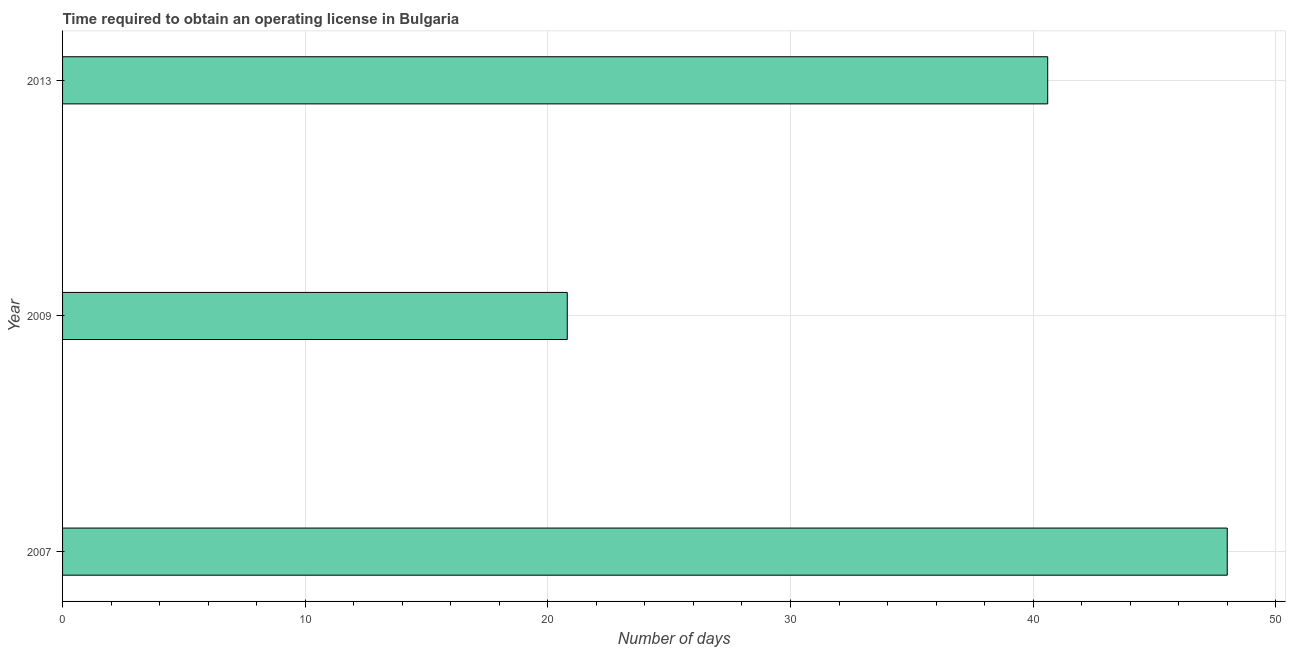Does the graph contain any zero values?
Ensure brevity in your answer.  No. Does the graph contain grids?
Provide a short and direct response. Yes. What is the title of the graph?
Ensure brevity in your answer.  Time required to obtain an operating license in Bulgaria. What is the label or title of the X-axis?
Keep it short and to the point. Number of days. What is the label or title of the Y-axis?
Offer a very short reply. Year. What is the number of days to obtain operating license in 2009?
Provide a short and direct response. 20.8. Across all years, what is the minimum number of days to obtain operating license?
Make the answer very short. 20.8. In which year was the number of days to obtain operating license minimum?
Give a very brief answer. 2009. What is the sum of the number of days to obtain operating license?
Give a very brief answer. 109.4. What is the difference between the number of days to obtain operating license in 2007 and 2009?
Provide a short and direct response. 27.2. What is the average number of days to obtain operating license per year?
Your response must be concise. 36.47. What is the median number of days to obtain operating license?
Your answer should be compact. 40.6. What is the ratio of the number of days to obtain operating license in 2009 to that in 2013?
Provide a succinct answer. 0.51. What is the difference between the highest and the second highest number of days to obtain operating license?
Give a very brief answer. 7.4. Is the sum of the number of days to obtain operating license in 2007 and 2009 greater than the maximum number of days to obtain operating license across all years?
Your response must be concise. Yes. What is the difference between the highest and the lowest number of days to obtain operating license?
Your answer should be very brief. 27.2. How many bars are there?
Offer a terse response. 3. Are the values on the major ticks of X-axis written in scientific E-notation?
Give a very brief answer. No. What is the Number of days of 2009?
Provide a succinct answer. 20.8. What is the Number of days in 2013?
Offer a terse response. 40.6. What is the difference between the Number of days in 2007 and 2009?
Ensure brevity in your answer.  27.2. What is the difference between the Number of days in 2009 and 2013?
Your response must be concise. -19.8. What is the ratio of the Number of days in 2007 to that in 2009?
Give a very brief answer. 2.31. What is the ratio of the Number of days in 2007 to that in 2013?
Your response must be concise. 1.18. What is the ratio of the Number of days in 2009 to that in 2013?
Offer a very short reply. 0.51. 